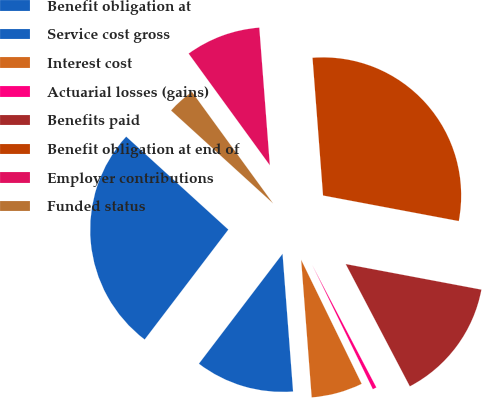Convert chart to OTSL. <chart><loc_0><loc_0><loc_500><loc_500><pie_chart><fcel>Benefit obligation at<fcel>Service cost gross<fcel>Interest cost<fcel>Actuarial losses (gains)<fcel>Benefits paid<fcel>Benefit obligation at end of<fcel>Employer contributions<fcel>Funded status<nl><fcel>26.4%<fcel>11.57%<fcel>6.01%<fcel>0.46%<fcel>14.35%<fcel>29.18%<fcel>8.79%<fcel>3.24%<nl></chart> 